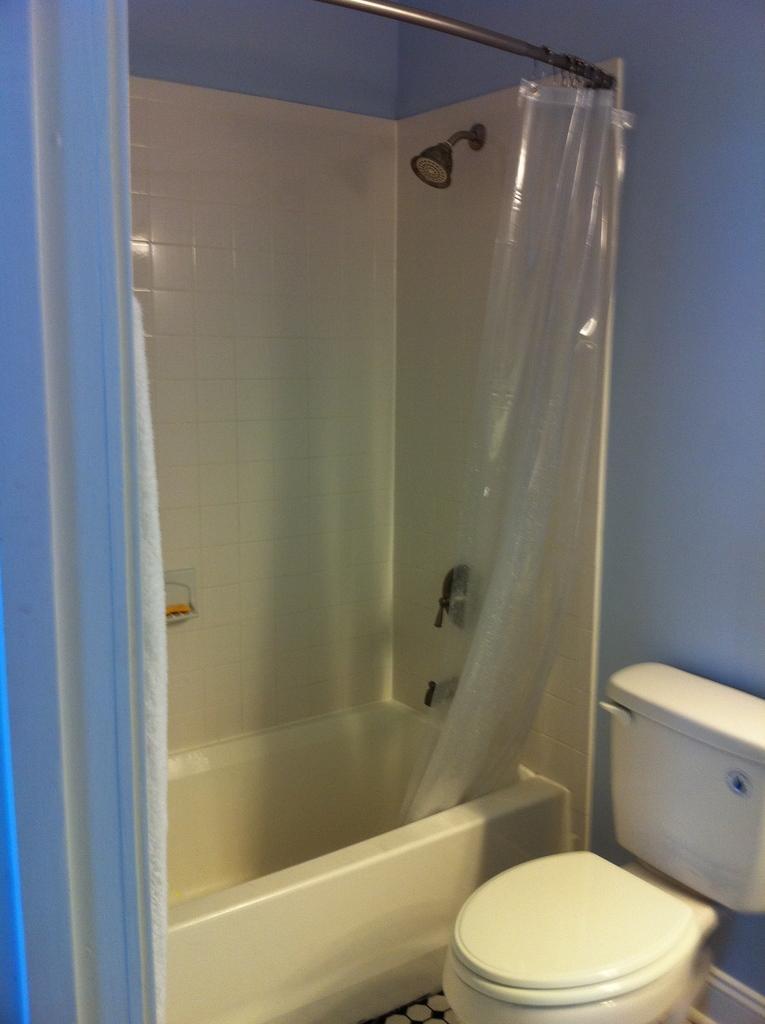Can you describe this image briefly? This image is taken in a washroom. On the right side of the image there is a toilet seat and there is a flush tank. In the background there is a wall. At the top of the image there is a curtain hanger and there is a transparent curtain. In the middle of the image there is a bathtub. 